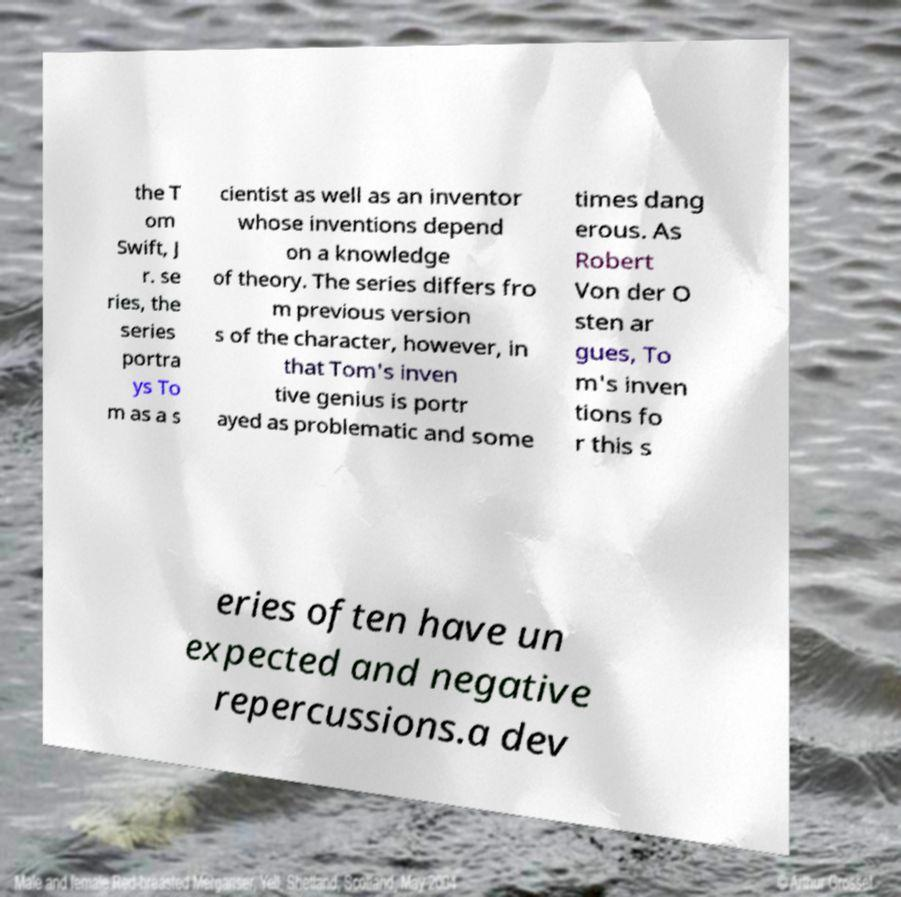Please identify and transcribe the text found in this image. the T om Swift, J r. se ries, the series portra ys To m as a s cientist as well as an inventor whose inventions depend on a knowledge of theory. The series differs fro m previous version s of the character, however, in that Tom's inven tive genius is portr ayed as problematic and some times dang erous. As Robert Von der O sten ar gues, To m's inven tions fo r this s eries often have un expected and negative repercussions.a dev 